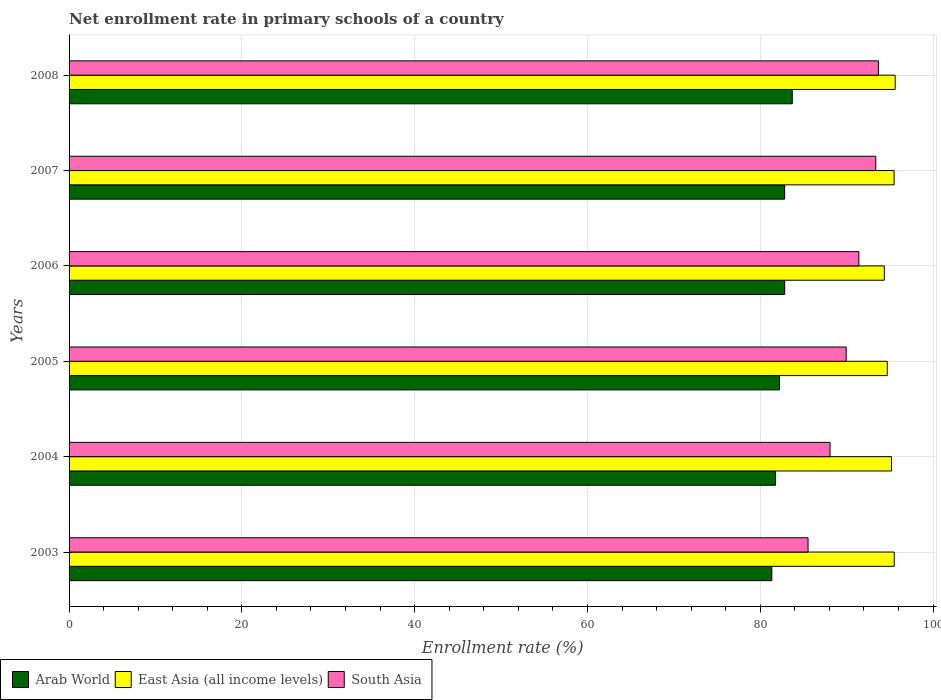How many different coloured bars are there?
Offer a terse response. 3. Are the number of bars per tick equal to the number of legend labels?
Give a very brief answer. Yes. How many bars are there on the 6th tick from the bottom?
Offer a terse response. 3. What is the label of the 4th group of bars from the top?
Provide a short and direct response. 2005. In how many cases, is the number of bars for a given year not equal to the number of legend labels?
Your answer should be very brief. 0. What is the enrollment rate in primary schools in East Asia (all income levels) in 2007?
Provide a short and direct response. 95.49. Across all years, what is the maximum enrollment rate in primary schools in East Asia (all income levels)?
Offer a very short reply. 95.61. Across all years, what is the minimum enrollment rate in primary schools in South Asia?
Make the answer very short. 85.53. What is the total enrollment rate in primary schools in South Asia in the graph?
Provide a succinct answer. 542. What is the difference between the enrollment rate in primary schools in East Asia (all income levels) in 2005 and that in 2007?
Your response must be concise. -0.79. What is the difference between the enrollment rate in primary schools in South Asia in 2008 and the enrollment rate in primary schools in East Asia (all income levels) in 2003?
Your answer should be very brief. -1.83. What is the average enrollment rate in primary schools in East Asia (all income levels) per year?
Provide a succinct answer. 95.14. In the year 2006, what is the difference between the enrollment rate in primary schools in East Asia (all income levels) and enrollment rate in primary schools in South Asia?
Your answer should be compact. 2.95. In how many years, is the enrollment rate in primary schools in South Asia greater than 16 %?
Provide a succinct answer. 6. What is the ratio of the enrollment rate in primary schools in Arab World in 2007 to that in 2008?
Keep it short and to the point. 0.99. Is the enrollment rate in primary schools in Arab World in 2003 less than that in 2005?
Your answer should be compact. Yes. Is the difference between the enrollment rate in primary schools in East Asia (all income levels) in 2006 and 2008 greater than the difference between the enrollment rate in primary schools in South Asia in 2006 and 2008?
Provide a short and direct response. Yes. What is the difference between the highest and the second highest enrollment rate in primary schools in Arab World?
Give a very brief answer. 0.88. What is the difference between the highest and the lowest enrollment rate in primary schools in Arab World?
Offer a very short reply. 2.37. In how many years, is the enrollment rate in primary schools in East Asia (all income levels) greater than the average enrollment rate in primary schools in East Asia (all income levels) taken over all years?
Provide a succinct answer. 4. What does the 2nd bar from the top in 2005 represents?
Make the answer very short. East Asia (all income levels). What does the 2nd bar from the bottom in 2007 represents?
Your response must be concise. East Asia (all income levels). Is it the case that in every year, the sum of the enrollment rate in primary schools in Arab World and enrollment rate in primary schools in East Asia (all income levels) is greater than the enrollment rate in primary schools in South Asia?
Your answer should be very brief. Yes. How many bars are there?
Ensure brevity in your answer.  18. Are all the bars in the graph horizontal?
Your answer should be very brief. Yes. How many years are there in the graph?
Keep it short and to the point. 6. What is the difference between two consecutive major ticks on the X-axis?
Make the answer very short. 20. Does the graph contain any zero values?
Ensure brevity in your answer.  No. Where does the legend appear in the graph?
Your response must be concise. Bottom left. How many legend labels are there?
Provide a succinct answer. 3. How are the legend labels stacked?
Your answer should be very brief. Horizontal. What is the title of the graph?
Your response must be concise. Net enrollment rate in primary schools of a country. Does "Philippines" appear as one of the legend labels in the graph?
Ensure brevity in your answer.  No. What is the label or title of the X-axis?
Provide a succinct answer. Enrollment rate (%). What is the label or title of the Y-axis?
Your response must be concise. Years. What is the Enrollment rate (%) in Arab World in 2003?
Your answer should be very brief. 81.34. What is the Enrollment rate (%) of East Asia (all income levels) in 2003?
Provide a short and direct response. 95.51. What is the Enrollment rate (%) in South Asia in 2003?
Your response must be concise. 85.53. What is the Enrollment rate (%) in Arab World in 2004?
Provide a short and direct response. 81.77. What is the Enrollment rate (%) of East Asia (all income levels) in 2004?
Your answer should be very brief. 95.19. What is the Enrollment rate (%) in South Asia in 2004?
Provide a short and direct response. 88.07. What is the Enrollment rate (%) in Arab World in 2005?
Your response must be concise. 82.22. What is the Enrollment rate (%) of East Asia (all income levels) in 2005?
Offer a terse response. 94.7. What is the Enrollment rate (%) in South Asia in 2005?
Your answer should be compact. 89.94. What is the Enrollment rate (%) in Arab World in 2006?
Offer a very short reply. 82.82. What is the Enrollment rate (%) of East Asia (all income levels) in 2006?
Your response must be concise. 94.36. What is the Enrollment rate (%) in South Asia in 2006?
Make the answer very short. 91.41. What is the Enrollment rate (%) in Arab World in 2007?
Your answer should be very brief. 82.82. What is the Enrollment rate (%) of East Asia (all income levels) in 2007?
Offer a very short reply. 95.49. What is the Enrollment rate (%) in South Asia in 2007?
Your answer should be compact. 93.37. What is the Enrollment rate (%) of Arab World in 2008?
Offer a terse response. 83.71. What is the Enrollment rate (%) of East Asia (all income levels) in 2008?
Keep it short and to the point. 95.61. What is the Enrollment rate (%) of South Asia in 2008?
Your response must be concise. 93.67. Across all years, what is the maximum Enrollment rate (%) in Arab World?
Ensure brevity in your answer.  83.71. Across all years, what is the maximum Enrollment rate (%) in East Asia (all income levels)?
Make the answer very short. 95.61. Across all years, what is the maximum Enrollment rate (%) of South Asia?
Provide a short and direct response. 93.67. Across all years, what is the minimum Enrollment rate (%) in Arab World?
Offer a terse response. 81.34. Across all years, what is the minimum Enrollment rate (%) of East Asia (all income levels)?
Ensure brevity in your answer.  94.36. Across all years, what is the minimum Enrollment rate (%) of South Asia?
Keep it short and to the point. 85.53. What is the total Enrollment rate (%) of Arab World in the graph?
Your response must be concise. 494.67. What is the total Enrollment rate (%) of East Asia (all income levels) in the graph?
Make the answer very short. 570.86. What is the total Enrollment rate (%) of South Asia in the graph?
Ensure brevity in your answer.  542. What is the difference between the Enrollment rate (%) in Arab World in 2003 and that in 2004?
Make the answer very short. -0.43. What is the difference between the Enrollment rate (%) of East Asia (all income levels) in 2003 and that in 2004?
Offer a very short reply. 0.32. What is the difference between the Enrollment rate (%) in South Asia in 2003 and that in 2004?
Keep it short and to the point. -2.55. What is the difference between the Enrollment rate (%) of Arab World in 2003 and that in 2005?
Give a very brief answer. -0.89. What is the difference between the Enrollment rate (%) of East Asia (all income levels) in 2003 and that in 2005?
Your answer should be compact. 0.8. What is the difference between the Enrollment rate (%) in South Asia in 2003 and that in 2005?
Your response must be concise. -4.41. What is the difference between the Enrollment rate (%) of Arab World in 2003 and that in 2006?
Make the answer very short. -1.49. What is the difference between the Enrollment rate (%) in East Asia (all income levels) in 2003 and that in 2006?
Ensure brevity in your answer.  1.15. What is the difference between the Enrollment rate (%) in South Asia in 2003 and that in 2006?
Give a very brief answer. -5.88. What is the difference between the Enrollment rate (%) in Arab World in 2003 and that in 2007?
Make the answer very short. -1.48. What is the difference between the Enrollment rate (%) in East Asia (all income levels) in 2003 and that in 2007?
Your response must be concise. 0.02. What is the difference between the Enrollment rate (%) of South Asia in 2003 and that in 2007?
Provide a succinct answer. -7.84. What is the difference between the Enrollment rate (%) of Arab World in 2003 and that in 2008?
Keep it short and to the point. -2.37. What is the difference between the Enrollment rate (%) of East Asia (all income levels) in 2003 and that in 2008?
Give a very brief answer. -0.11. What is the difference between the Enrollment rate (%) of South Asia in 2003 and that in 2008?
Offer a very short reply. -8.14. What is the difference between the Enrollment rate (%) of Arab World in 2004 and that in 2005?
Make the answer very short. -0.46. What is the difference between the Enrollment rate (%) in East Asia (all income levels) in 2004 and that in 2005?
Your answer should be compact. 0.49. What is the difference between the Enrollment rate (%) of South Asia in 2004 and that in 2005?
Make the answer very short. -1.87. What is the difference between the Enrollment rate (%) of Arab World in 2004 and that in 2006?
Your response must be concise. -1.06. What is the difference between the Enrollment rate (%) of East Asia (all income levels) in 2004 and that in 2006?
Keep it short and to the point. 0.83. What is the difference between the Enrollment rate (%) of South Asia in 2004 and that in 2006?
Keep it short and to the point. -3.34. What is the difference between the Enrollment rate (%) in Arab World in 2004 and that in 2007?
Provide a short and direct response. -1.05. What is the difference between the Enrollment rate (%) in East Asia (all income levels) in 2004 and that in 2007?
Offer a very short reply. -0.3. What is the difference between the Enrollment rate (%) of South Asia in 2004 and that in 2007?
Offer a terse response. -5.29. What is the difference between the Enrollment rate (%) of Arab World in 2004 and that in 2008?
Give a very brief answer. -1.94. What is the difference between the Enrollment rate (%) in East Asia (all income levels) in 2004 and that in 2008?
Make the answer very short. -0.43. What is the difference between the Enrollment rate (%) in South Asia in 2004 and that in 2008?
Your answer should be compact. -5.6. What is the difference between the Enrollment rate (%) of Arab World in 2005 and that in 2006?
Your answer should be very brief. -0.6. What is the difference between the Enrollment rate (%) of East Asia (all income levels) in 2005 and that in 2006?
Keep it short and to the point. 0.34. What is the difference between the Enrollment rate (%) of South Asia in 2005 and that in 2006?
Offer a terse response. -1.47. What is the difference between the Enrollment rate (%) of Arab World in 2005 and that in 2007?
Give a very brief answer. -0.59. What is the difference between the Enrollment rate (%) in East Asia (all income levels) in 2005 and that in 2007?
Your response must be concise. -0.79. What is the difference between the Enrollment rate (%) of South Asia in 2005 and that in 2007?
Offer a terse response. -3.42. What is the difference between the Enrollment rate (%) of Arab World in 2005 and that in 2008?
Your answer should be compact. -1.48. What is the difference between the Enrollment rate (%) of East Asia (all income levels) in 2005 and that in 2008?
Offer a very short reply. -0.91. What is the difference between the Enrollment rate (%) of South Asia in 2005 and that in 2008?
Provide a short and direct response. -3.73. What is the difference between the Enrollment rate (%) in Arab World in 2006 and that in 2007?
Offer a terse response. 0. What is the difference between the Enrollment rate (%) in East Asia (all income levels) in 2006 and that in 2007?
Offer a terse response. -1.13. What is the difference between the Enrollment rate (%) of South Asia in 2006 and that in 2007?
Give a very brief answer. -1.95. What is the difference between the Enrollment rate (%) of Arab World in 2006 and that in 2008?
Make the answer very short. -0.88. What is the difference between the Enrollment rate (%) of East Asia (all income levels) in 2006 and that in 2008?
Provide a succinct answer. -1.26. What is the difference between the Enrollment rate (%) of South Asia in 2006 and that in 2008?
Your answer should be compact. -2.26. What is the difference between the Enrollment rate (%) in Arab World in 2007 and that in 2008?
Your answer should be compact. -0.89. What is the difference between the Enrollment rate (%) of East Asia (all income levels) in 2007 and that in 2008?
Make the answer very short. -0.13. What is the difference between the Enrollment rate (%) in South Asia in 2007 and that in 2008?
Make the answer very short. -0.31. What is the difference between the Enrollment rate (%) of Arab World in 2003 and the Enrollment rate (%) of East Asia (all income levels) in 2004?
Keep it short and to the point. -13.85. What is the difference between the Enrollment rate (%) of Arab World in 2003 and the Enrollment rate (%) of South Asia in 2004?
Offer a terse response. -6.74. What is the difference between the Enrollment rate (%) of East Asia (all income levels) in 2003 and the Enrollment rate (%) of South Asia in 2004?
Provide a succinct answer. 7.43. What is the difference between the Enrollment rate (%) of Arab World in 2003 and the Enrollment rate (%) of East Asia (all income levels) in 2005?
Provide a succinct answer. -13.37. What is the difference between the Enrollment rate (%) in Arab World in 2003 and the Enrollment rate (%) in South Asia in 2005?
Give a very brief answer. -8.61. What is the difference between the Enrollment rate (%) of East Asia (all income levels) in 2003 and the Enrollment rate (%) of South Asia in 2005?
Provide a succinct answer. 5.56. What is the difference between the Enrollment rate (%) of Arab World in 2003 and the Enrollment rate (%) of East Asia (all income levels) in 2006?
Offer a very short reply. -13.02. What is the difference between the Enrollment rate (%) in Arab World in 2003 and the Enrollment rate (%) in South Asia in 2006?
Make the answer very short. -10.08. What is the difference between the Enrollment rate (%) of East Asia (all income levels) in 2003 and the Enrollment rate (%) of South Asia in 2006?
Keep it short and to the point. 4.09. What is the difference between the Enrollment rate (%) of Arab World in 2003 and the Enrollment rate (%) of East Asia (all income levels) in 2007?
Provide a succinct answer. -14.15. What is the difference between the Enrollment rate (%) of Arab World in 2003 and the Enrollment rate (%) of South Asia in 2007?
Give a very brief answer. -12.03. What is the difference between the Enrollment rate (%) in East Asia (all income levels) in 2003 and the Enrollment rate (%) in South Asia in 2007?
Offer a terse response. 2.14. What is the difference between the Enrollment rate (%) of Arab World in 2003 and the Enrollment rate (%) of East Asia (all income levels) in 2008?
Your answer should be compact. -14.28. What is the difference between the Enrollment rate (%) in Arab World in 2003 and the Enrollment rate (%) in South Asia in 2008?
Keep it short and to the point. -12.34. What is the difference between the Enrollment rate (%) in East Asia (all income levels) in 2003 and the Enrollment rate (%) in South Asia in 2008?
Your answer should be very brief. 1.83. What is the difference between the Enrollment rate (%) in Arab World in 2004 and the Enrollment rate (%) in East Asia (all income levels) in 2005?
Provide a succinct answer. -12.94. What is the difference between the Enrollment rate (%) of Arab World in 2004 and the Enrollment rate (%) of South Asia in 2005?
Offer a terse response. -8.18. What is the difference between the Enrollment rate (%) of East Asia (all income levels) in 2004 and the Enrollment rate (%) of South Asia in 2005?
Your answer should be compact. 5.25. What is the difference between the Enrollment rate (%) in Arab World in 2004 and the Enrollment rate (%) in East Asia (all income levels) in 2006?
Keep it short and to the point. -12.59. What is the difference between the Enrollment rate (%) in Arab World in 2004 and the Enrollment rate (%) in South Asia in 2006?
Make the answer very short. -9.65. What is the difference between the Enrollment rate (%) in East Asia (all income levels) in 2004 and the Enrollment rate (%) in South Asia in 2006?
Your answer should be compact. 3.78. What is the difference between the Enrollment rate (%) in Arab World in 2004 and the Enrollment rate (%) in East Asia (all income levels) in 2007?
Offer a terse response. -13.72. What is the difference between the Enrollment rate (%) of Arab World in 2004 and the Enrollment rate (%) of South Asia in 2007?
Ensure brevity in your answer.  -11.6. What is the difference between the Enrollment rate (%) of East Asia (all income levels) in 2004 and the Enrollment rate (%) of South Asia in 2007?
Your response must be concise. 1.82. What is the difference between the Enrollment rate (%) of Arab World in 2004 and the Enrollment rate (%) of East Asia (all income levels) in 2008?
Provide a succinct answer. -13.85. What is the difference between the Enrollment rate (%) of Arab World in 2004 and the Enrollment rate (%) of South Asia in 2008?
Provide a short and direct response. -11.91. What is the difference between the Enrollment rate (%) in East Asia (all income levels) in 2004 and the Enrollment rate (%) in South Asia in 2008?
Give a very brief answer. 1.52. What is the difference between the Enrollment rate (%) in Arab World in 2005 and the Enrollment rate (%) in East Asia (all income levels) in 2006?
Keep it short and to the point. -12.13. What is the difference between the Enrollment rate (%) of Arab World in 2005 and the Enrollment rate (%) of South Asia in 2006?
Provide a succinct answer. -9.19. What is the difference between the Enrollment rate (%) in East Asia (all income levels) in 2005 and the Enrollment rate (%) in South Asia in 2006?
Offer a terse response. 3.29. What is the difference between the Enrollment rate (%) in Arab World in 2005 and the Enrollment rate (%) in East Asia (all income levels) in 2007?
Keep it short and to the point. -13.26. What is the difference between the Enrollment rate (%) in Arab World in 2005 and the Enrollment rate (%) in South Asia in 2007?
Your answer should be very brief. -11.14. What is the difference between the Enrollment rate (%) of East Asia (all income levels) in 2005 and the Enrollment rate (%) of South Asia in 2007?
Provide a succinct answer. 1.34. What is the difference between the Enrollment rate (%) in Arab World in 2005 and the Enrollment rate (%) in East Asia (all income levels) in 2008?
Keep it short and to the point. -13.39. What is the difference between the Enrollment rate (%) in Arab World in 2005 and the Enrollment rate (%) in South Asia in 2008?
Offer a terse response. -11.45. What is the difference between the Enrollment rate (%) in East Asia (all income levels) in 2005 and the Enrollment rate (%) in South Asia in 2008?
Keep it short and to the point. 1.03. What is the difference between the Enrollment rate (%) in Arab World in 2006 and the Enrollment rate (%) in East Asia (all income levels) in 2007?
Your response must be concise. -12.67. What is the difference between the Enrollment rate (%) in Arab World in 2006 and the Enrollment rate (%) in South Asia in 2007?
Keep it short and to the point. -10.54. What is the difference between the Enrollment rate (%) in Arab World in 2006 and the Enrollment rate (%) in East Asia (all income levels) in 2008?
Your response must be concise. -12.79. What is the difference between the Enrollment rate (%) in Arab World in 2006 and the Enrollment rate (%) in South Asia in 2008?
Offer a terse response. -10.85. What is the difference between the Enrollment rate (%) of East Asia (all income levels) in 2006 and the Enrollment rate (%) of South Asia in 2008?
Provide a short and direct response. 0.69. What is the difference between the Enrollment rate (%) in Arab World in 2007 and the Enrollment rate (%) in East Asia (all income levels) in 2008?
Keep it short and to the point. -12.8. What is the difference between the Enrollment rate (%) of Arab World in 2007 and the Enrollment rate (%) of South Asia in 2008?
Your response must be concise. -10.85. What is the difference between the Enrollment rate (%) of East Asia (all income levels) in 2007 and the Enrollment rate (%) of South Asia in 2008?
Your answer should be very brief. 1.82. What is the average Enrollment rate (%) of Arab World per year?
Offer a terse response. 82.45. What is the average Enrollment rate (%) of East Asia (all income levels) per year?
Your answer should be compact. 95.14. What is the average Enrollment rate (%) of South Asia per year?
Give a very brief answer. 90.33. In the year 2003, what is the difference between the Enrollment rate (%) of Arab World and Enrollment rate (%) of East Asia (all income levels)?
Offer a very short reply. -14.17. In the year 2003, what is the difference between the Enrollment rate (%) in Arab World and Enrollment rate (%) in South Asia?
Offer a terse response. -4.19. In the year 2003, what is the difference between the Enrollment rate (%) in East Asia (all income levels) and Enrollment rate (%) in South Asia?
Make the answer very short. 9.98. In the year 2004, what is the difference between the Enrollment rate (%) in Arab World and Enrollment rate (%) in East Asia (all income levels)?
Your response must be concise. -13.42. In the year 2004, what is the difference between the Enrollment rate (%) in Arab World and Enrollment rate (%) in South Asia?
Offer a terse response. -6.31. In the year 2004, what is the difference between the Enrollment rate (%) in East Asia (all income levels) and Enrollment rate (%) in South Asia?
Make the answer very short. 7.11. In the year 2005, what is the difference between the Enrollment rate (%) in Arab World and Enrollment rate (%) in East Asia (all income levels)?
Make the answer very short. -12.48. In the year 2005, what is the difference between the Enrollment rate (%) of Arab World and Enrollment rate (%) of South Asia?
Your response must be concise. -7.72. In the year 2005, what is the difference between the Enrollment rate (%) in East Asia (all income levels) and Enrollment rate (%) in South Asia?
Offer a terse response. 4.76. In the year 2006, what is the difference between the Enrollment rate (%) in Arab World and Enrollment rate (%) in East Asia (all income levels)?
Your answer should be compact. -11.53. In the year 2006, what is the difference between the Enrollment rate (%) of Arab World and Enrollment rate (%) of South Asia?
Provide a short and direct response. -8.59. In the year 2006, what is the difference between the Enrollment rate (%) in East Asia (all income levels) and Enrollment rate (%) in South Asia?
Your answer should be compact. 2.95. In the year 2007, what is the difference between the Enrollment rate (%) of Arab World and Enrollment rate (%) of East Asia (all income levels)?
Offer a terse response. -12.67. In the year 2007, what is the difference between the Enrollment rate (%) in Arab World and Enrollment rate (%) in South Asia?
Keep it short and to the point. -10.55. In the year 2007, what is the difference between the Enrollment rate (%) in East Asia (all income levels) and Enrollment rate (%) in South Asia?
Make the answer very short. 2.12. In the year 2008, what is the difference between the Enrollment rate (%) in Arab World and Enrollment rate (%) in East Asia (all income levels)?
Offer a terse response. -11.91. In the year 2008, what is the difference between the Enrollment rate (%) of Arab World and Enrollment rate (%) of South Asia?
Your answer should be very brief. -9.97. In the year 2008, what is the difference between the Enrollment rate (%) in East Asia (all income levels) and Enrollment rate (%) in South Asia?
Your answer should be very brief. 1.94. What is the ratio of the Enrollment rate (%) in South Asia in 2003 to that in 2004?
Offer a terse response. 0.97. What is the ratio of the Enrollment rate (%) in Arab World in 2003 to that in 2005?
Your answer should be compact. 0.99. What is the ratio of the Enrollment rate (%) in East Asia (all income levels) in 2003 to that in 2005?
Offer a terse response. 1.01. What is the ratio of the Enrollment rate (%) of South Asia in 2003 to that in 2005?
Ensure brevity in your answer.  0.95. What is the ratio of the Enrollment rate (%) of Arab World in 2003 to that in 2006?
Give a very brief answer. 0.98. What is the ratio of the Enrollment rate (%) in East Asia (all income levels) in 2003 to that in 2006?
Offer a very short reply. 1.01. What is the ratio of the Enrollment rate (%) in South Asia in 2003 to that in 2006?
Make the answer very short. 0.94. What is the ratio of the Enrollment rate (%) of Arab World in 2003 to that in 2007?
Offer a very short reply. 0.98. What is the ratio of the Enrollment rate (%) in South Asia in 2003 to that in 2007?
Your answer should be compact. 0.92. What is the ratio of the Enrollment rate (%) of Arab World in 2003 to that in 2008?
Keep it short and to the point. 0.97. What is the ratio of the Enrollment rate (%) of South Asia in 2003 to that in 2008?
Provide a succinct answer. 0.91. What is the ratio of the Enrollment rate (%) in Arab World in 2004 to that in 2005?
Your answer should be compact. 0.99. What is the ratio of the Enrollment rate (%) of East Asia (all income levels) in 2004 to that in 2005?
Make the answer very short. 1.01. What is the ratio of the Enrollment rate (%) of South Asia in 2004 to that in 2005?
Your response must be concise. 0.98. What is the ratio of the Enrollment rate (%) of Arab World in 2004 to that in 2006?
Make the answer very short. 0.99. What is the ratio of the Enrollment rate (%) in East Asia (all income levels) in 2004 to that in 2006?
Ensure brevity in your answer.  1.01. What is the ratio of the Enrollment rate (%) in South Asia in 2004 to that in 2006?
Provide a short and direct response. 0.96. What is the ratio of the Enrollment rate (%) of Arab World in 2004 to that in 2007?
Ensure brevity in your answer.  0.99. What is the ratio of the Enrollment rate (%) in South Asia in 2004 to that in 2007?
Provide a succinct answer. 0.94. What is the ratio of the Enrollment rate (%) in Arab World in 2004 to that in 2008?
Offer a very short reply. 0.98. What is the ratio of the Enrollment rate (%) of South Asia in 2004 to that in 2008?
Your answer should be compact. 0.94. What is the ratio of the Enrollment rate (%) of East Asia (all income levels) in 2005 to that in 2006?
Provide a short and direct response. 1. What is the ratio of the Enrollment rate (%) of South Asia in 2005 to that in 2006?
Ensure brevity in your answer.  0.98. What is the ratio of the Enrollment rate (%) in Arab World in 2005 to that in 2007?
Provide a succinct answer. 0.99. What is the ratio of the Enrollment rate (%) in East Asia (all income levels) in 2005 to that in 2007?
Offer a terse response. 0.99. What is the ratio of the Enrollment rate (%) in South Asia in 2005 to that in 2007?
Your answer should be compact. 0.96. What is the ratio of the Enrollment rate (%) in Arab World in 2005 to that in 2008?
Offer a very short reply. 0.98. What is the ratio of the Enrollment rate (%) in East Asia (all income levels) in 2005 to that in 2008?
Give a very brief answer. 0.99. What is the ratio of the Enrollment rate (%) of South Asia in 2005 to that in 2008?
Ensure brevity in your answer.  0.96. What is the ratio of the Enrollment rate (%) in South Asia in 2006 to that in 2007?
Provide a short and direct response. 0.98. What is the ratio of the Enrollment rate (%) in East Asia (all income levels) in 2006 to that in 2008?
Keep it short and to the point. 0.99. What is the ratio of the Enrollment rate (%) of South Asia in 2006 to that in 2008?
Make the answer very short. 0.98. What is the difference between the highest and the second highest Enrollment rate (%) in Arab World?
Offer a terse response. 0.88. What is the difference between the highest and the second highest Enrollment rate (%) of East Asia (all income levels)?
Offer a terse response. 0.11. What is the difference between the highest and the second highest Enrollment rate (%) in South Asia?
Keep it short and to the point. 0.31. What is the difference between the highest and the lowest Enrollment rate (%) of Arab World?
Provide a succinct answer. 2.37. What is the difference between the highest and the lowest Enrollment rate (%) of East Asia (all income levels)?
Provide a succinct answer. 1.26. What is the difference between the highest and the lowest Enrollment rate (%) in South Asia?
Ensure brevity in your answer.  8.14. 